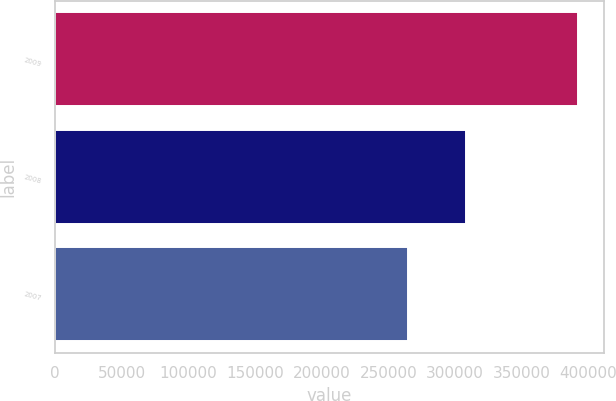Convert chart to OTSL. <chart><loc_0><loc_0><loc_500><loc_500><bar_chart><fcel>2009<fcel>2008<fcel>2007<nl><fcel>392236<fcel>308260<fcel>264931<nl></chart> 